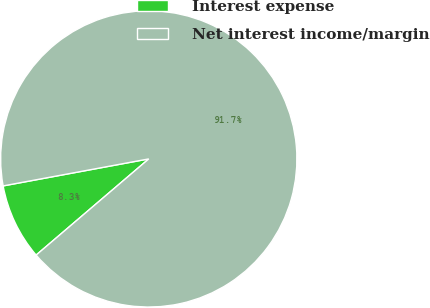Convert chart to OTSL. <chart><loc_0><loc_0><loc_500><loc_500><pie_chart><fcel>Interest expense<fcel>Net interest income/margin<nl><fcel>8.33%<fcel>91.67%<nl></chart> 